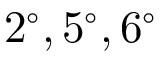<formula> <loc_0><loc_0><loc_500><loc_500>2 ^ { \circ } , 5 ^ { \circ } , 6 ^ { \circ }</formula> 